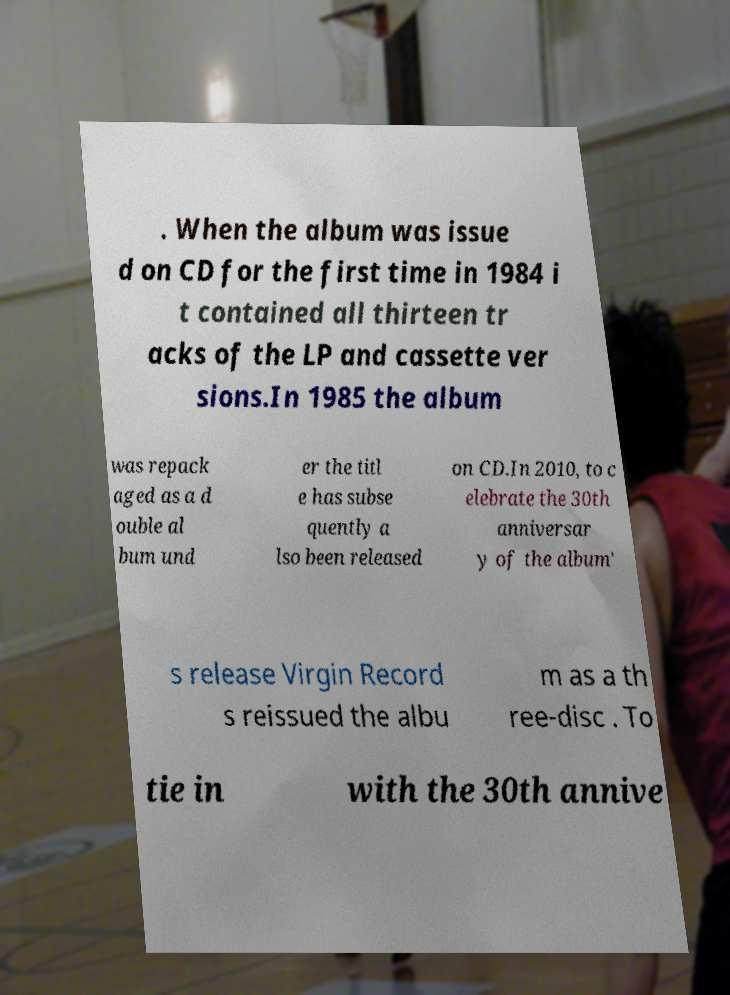Please read and relay the text visible in this image. What does it say? . When the album was issue d on CD for the first time in 1984 i t contained all thirteen tr acks of the LP and cassette ver sions.In 1985 the album was repack aged as a d ouble al bum und er the titl e has subse quently a lso been released on CD.In 2010, to c elebrate the 30th anniversar y of the album' s release Virgin Record s reissued the albu m as a th ree-disc . To tie in with the 30th annive 